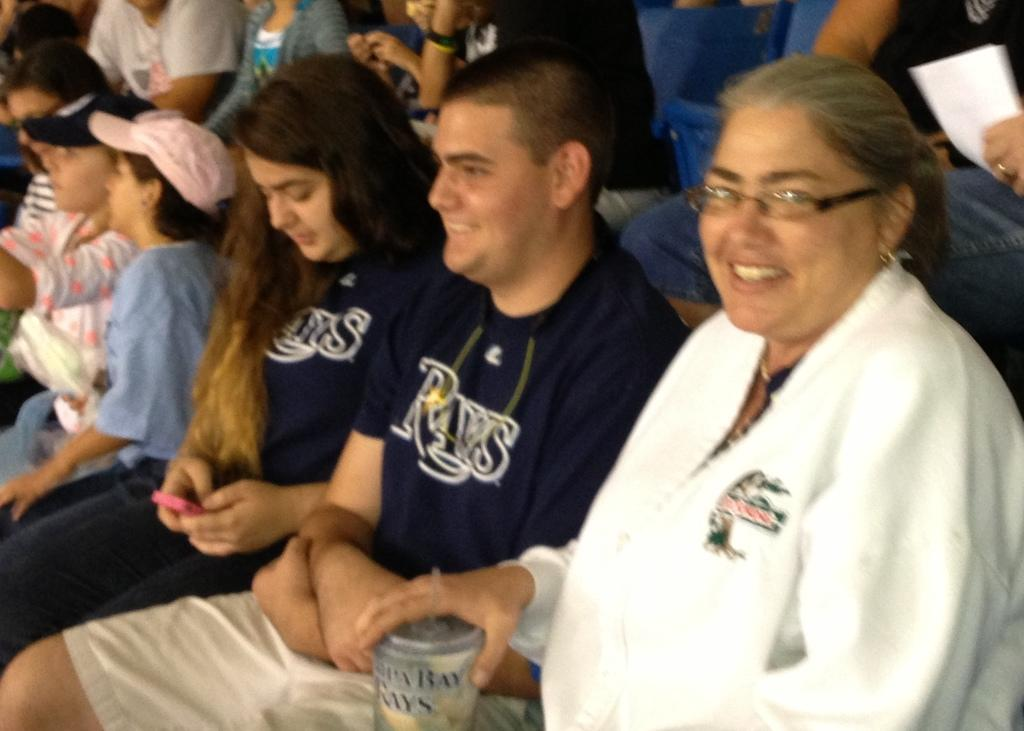What is the main activity of the people in the image? There is a group of people sitting in the image. Can you describe what one of the women is holding? There is a woman holding an object in the image. What is the other woman holding in the image? The other woman is holding a mobile phone in the image. What type of animal can be seen on the side of the woman holding the object? There is no animal present in the image, and the woman holding the object is not shown from the side. 